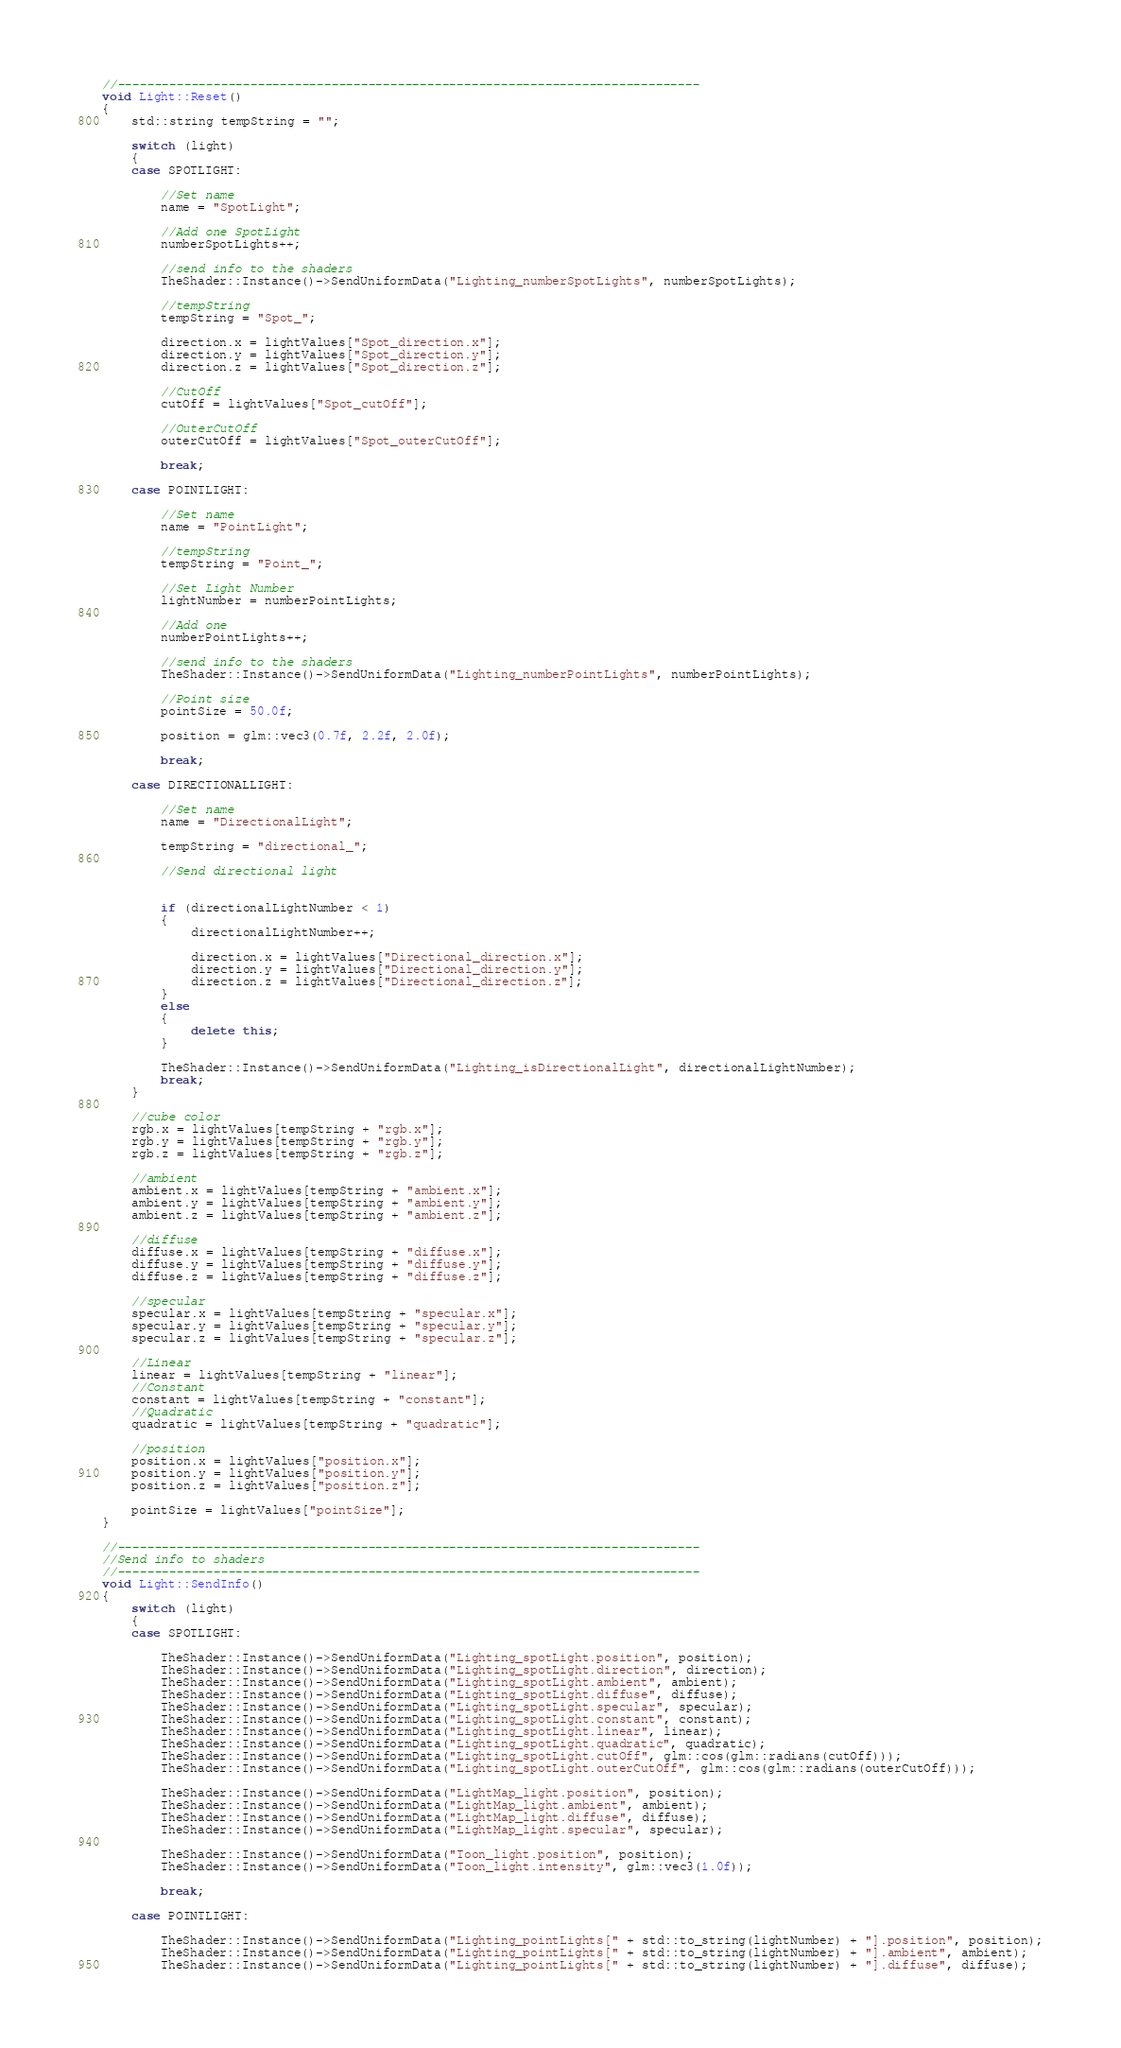Convert code to text. <code><loc_0><loc_0><loc_500><loc_500><_C++_>//-------------------------------------------------------------------------------
void Light::Reset()
{
	std::string tempString = "";

	switch (light)
	{
	case SPOTLIGHT:

		//Set name
		name = "SpotLight";

		//Add one SpotLight
		numberSpotLights++;

		//send info to the shaders
		TheShader::Instance()->SendUniformData("Lighting_numberSpotLights", numberSpotLights);

		//tempString
		tempString = "Spot_";

		direction.x = lightValues["Spot_direction.x"];
		direction.y = lightValues["Spot_direction.y"];
		direction.z = lightValues["Spot_direction.z"];

		//CutOff
		cutOff = lightValues["Spot_cutOff"];

		//OuterCutOff 
		outerCutOff = lightValues["Spot_outerCutOff"];

		break;

	case POINTLIGHT:

		//Set name
		name = "PointLight";

		//tempString
		tempString = "Point_";

		//Set Light Number
		lightNumber = numberPointLights;

		//Add one
		numberPointLights++;

		//send info to the shaders
		TheShader::Instance()->SendUniformData("Lighting_numberPointLights", numberPointLights);

		//Point size
		pointSize = 50.0f;

		position = glm::vec3(0.7f, 2.2f, 2.0f);

		break;

	case DIRECTIONALLIGHT:
		
		//Set name
		name = "DirectionalLight";

		tempString = "directional_";

		//Send directional light


		if (directionalLightNumber < 1)
		{
			directionalLightNumber++;

			direction.x = lightValues["Directional_direction.x"];
			direction.y = lightValues["Directional_direction.y"];
			direction.z = lightValues["Directional_direction.z"];
		}
		else
		{
			delete this;
		}

		TheShader::Instance()->SendUniformData("Lighting_isDirectionalLight", directionalLightNumber);
		break;
	}

	//cube color
	rgb.x = lightValues[tempString + "rgb.x"];
	rgb.y = lightValues[tempString + "rgb.y"];
	rgb.z = lightValues[tempString + "rgb.z"];

	//ambient
	ambient.x = lightValues[tempString + "ambient.x"];
	ambient.y = lightValues[tempString + "ambient.y"];
	ambient.z = lightValues[tempString + "ambient.z"];

	//diffuse
	diffuse.x = lightValues[tempString + "diffuse.x"];
	diffuse.y = lightValues[tempString + "diffuse.y"];
	diffuse.z = lightValues[tempString + "diffuse.z"];

	//specular
	specular.x = lightValues[tempString + "specular.x"];
	specular.y = lightValues[tempString + "specular.y"];
	specular.z = lightValues[tempString + "specular.z"];

	//Linear
	linear = lightValues[tempString + "linear"];
	//Constant
	constant = lightValues[tempString + "constant"];
	//Quadratic
	quadratic = lightValues[tempString + "quadratic"];

	//position
	position.x = lightValues["position.x"];
	position.y = lightValues["position.y"];
	position.z = lightValues["position.z"];

	pointSize = lightValues["pointSize"];
}

//-------------------------------------------------------------------------------
//Send info to shaders
//-------------------------------------------------------------------------------
void Light::SendInfo()
{
	switch (light)
	{
	case SPOTLIGHT:

		TheShader::Instance()->SendUniformData("Lighting_spotLight.position", position);
		TheShader::Instance()->SendUniformData("Lighting_spotLight.direction", direction);
		TheShader::Instance()->SendUniformData("Lighting_spotLight.ambient", ambient);
		TheShader::Instance()->SendUniformData("Lighting_spotLight.diffuse", diffuse);
		TheShader::Instance()->SendUniformData("Lighting_spotLight.specular", specular);
		TheShader::Instance()->SendUniformData("Lighting_spotLight.constant", constant);
		TheShader::Instance()->SendUniformData("Lighting_spotLight.linear", linear);
		TheShader::Instance()->SendUniformData("Lighting_spotLight.quadratic", quadratic);
		TheShader::Instance()->SendUniformData("Lighting_spotLight.cutOff", glm::cos(glm::radians(cutOff)));
		TheShader::Instance()->SendUniformData("Lighting_spotLight.outerCutOff", glm::cos(glm::radians(outerCutOff)));

		TheShader::Instance()->SendUniformData("LightMap_light.position", position);
		TheShader::Instance()->SendUniformData("LightMap_light.ambient", ambient);
		TheShader::Instance()->SendUniformData("LightMap_light.diffuse", diffuse);
		TheShader::Instance()->SendUniformData("LightMap_light.specular", specular);

		TheShader::Instance()->SendUniformData("Toon_light.position", position);
		TheShader::Instance()->SendUniformData("Toon_light.intensity", glm::vec3(1.0f));

		break;

	case POINTLIGHT:

		TheShader::Instance()->SendUniformData("Lighting_pointLights[" + std::to_string(lightNumber) + "].position", position);
		TheShader::Instance()->SendUniformData("Lighting_pointLights[" + std::to_string(lightNumber) + "].ambient", ambient);
		TheShader::Instance()->SendUniformData("Lighting_pointLights[" + std::to_string(lightNumber) + "].diffuse", diffuse);</code> 